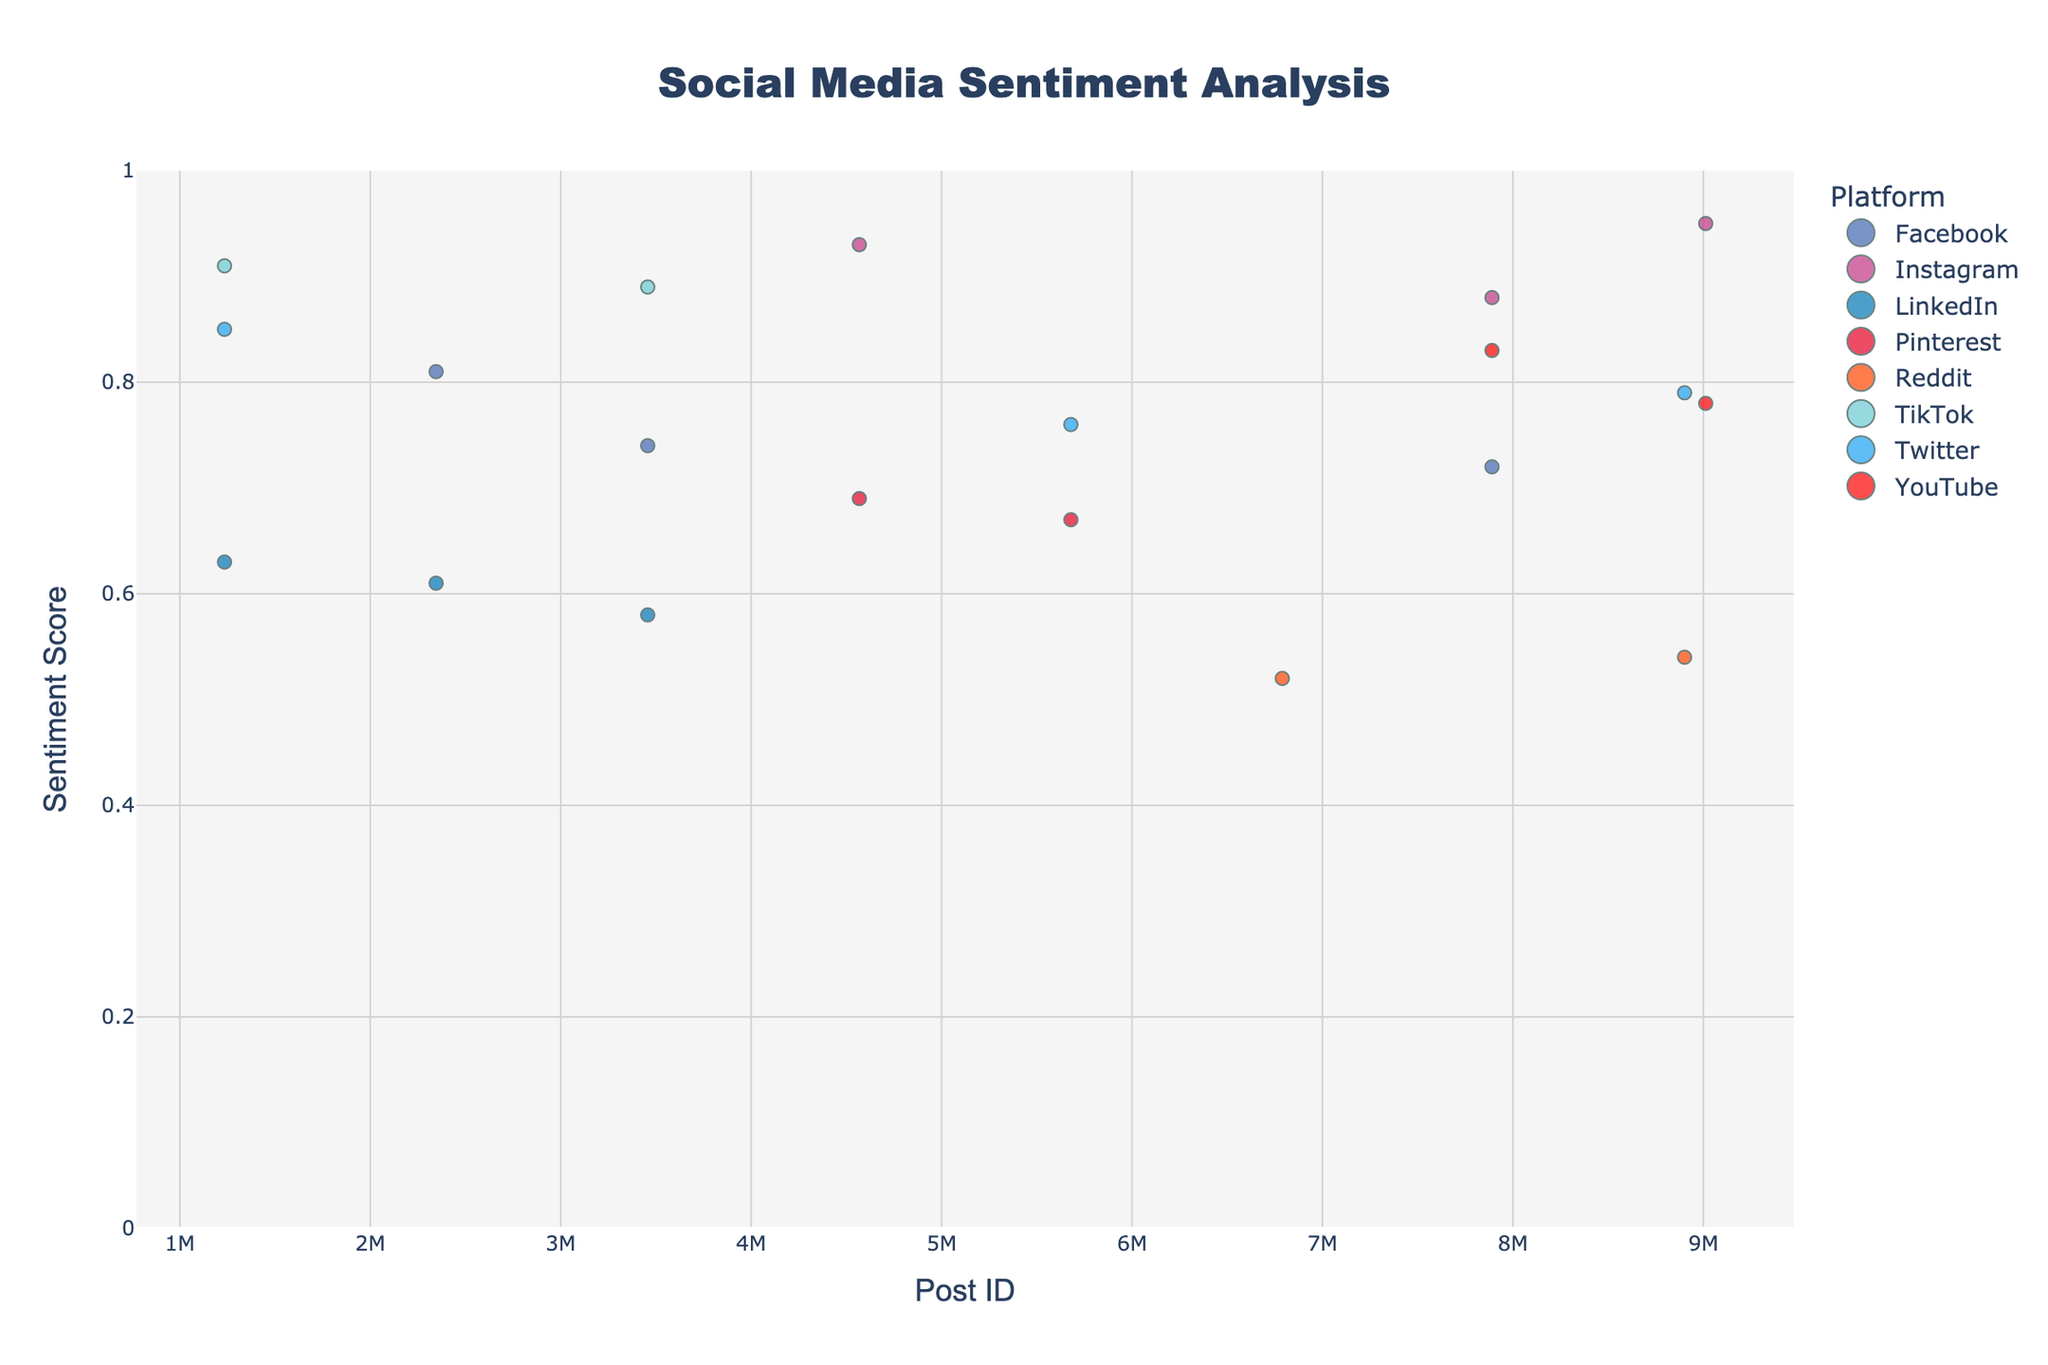Is there a platform that consistently shows high sentiment scores? By observing the plot, Instagram and TikTok appear to have consistently high sentiment scores, as their data points are concentrated near the top of the y-axis.
Answer: Instagram and TikTok Which platform has the data point with the highest sentiment score? The data point with the highest sentiment score is 0.95, which belongs to Instagram.
Answer: Instagram How many platforms are analyzed in the plot? By counting the different marker colors representing each platform in the legend, there are 8 platforms.
Answer: 8 What is the sentiment score range covered in the plot? The y-axis ranges from 0 to 1, as indicated by its labels and grid.
Answer: 0 to 1 Which platform has the data point with the highest engagement? The largest marker size indicates the highest engagement, which belongs to Instagram with a PostID of 4567890.
Answer: Instagram What is the average sentiment score of posts from Reddit? The sentiment scores for Reddit are 0.54 and 0.52. The average is calculated as (0.54 + 0.52) / 2 = 0.53.
Answer: 0.53 Compare the sentiment scores of the top posts between Twitter and Facebook. Which platform has higher average sentiment? The sentiment scores for Twitter are 0.85, 0.76, and 0.79; for Facebook are 0.72, 0.81, and 0.74. The average for Twitter is (0.85 + 0.76 + 0.79) / 3 ≈ 0.80. The average for Facebook is (0.72 + 0.81 + 0.74) / 3 ≈ 0.76. Twitter has a higher average sentiment.
Answer: Twitter Which platform has the most variable sentiment scores based on the plotted points' spread? LinkedIn shows a wide range of sentiment scores from 0.58 to 0.63, indicating high variability.
Answer: LinkedIn 